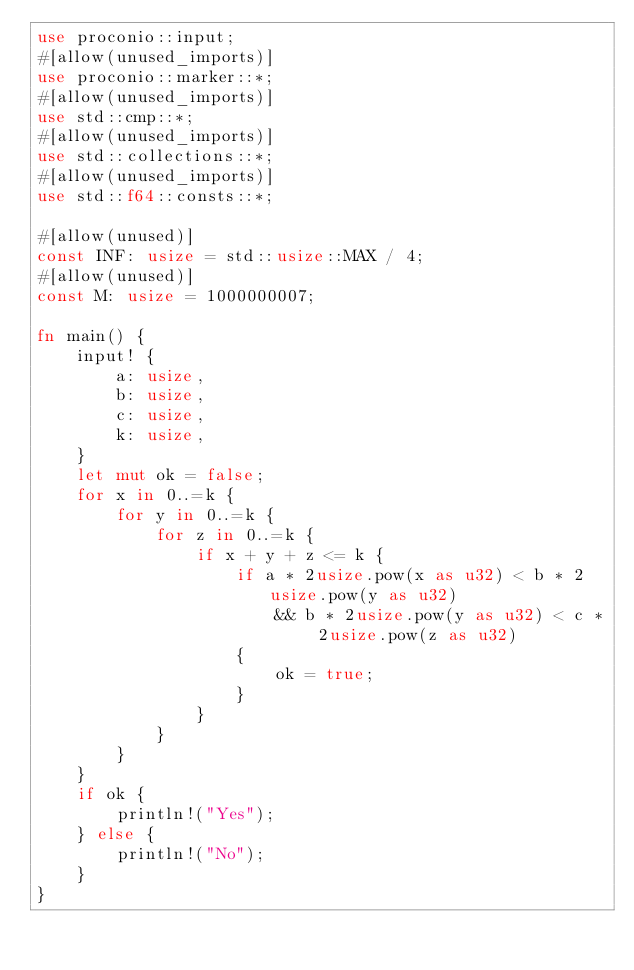<code> <loc_0><loc_0><loc_500><loc_500><_Rust_>use proconio::input;
#[allow(unused_imports)]
use proconio::marker::*;
#[allow(unused_imports)]
use std::cmp::*;
#[allow(unused_imports)]
use std::collections::*;
#[allow(unused_imports)]
use std::f64::consts::*;

#[allow(unused)]
const INF: usize = std::usize::MAX / 4;
#[allow(unused)]
const M: usize = 1000000007;

fn main() {
    input! {
        a: usize,
        b: usize,
        c: usize,
        k: usize,
    }
    let mut ok = false;
    for x in 0..=k {
        for y in 0..=k {
            for z in 0..=k {
                if x + y + z <= k {
                    if a * 2usize.pow(x as u32) < b * 2usize.pow(y as u32)
                        && b * 2usize.pow(y as u32) < c * 2usize.pow(z as u32)
                    {
                        ok = true;
                    }
                }
            }
        }
    }
    if ok {
        println!("Yes");
    } else {
        println!("No");
    }
}
</code> 